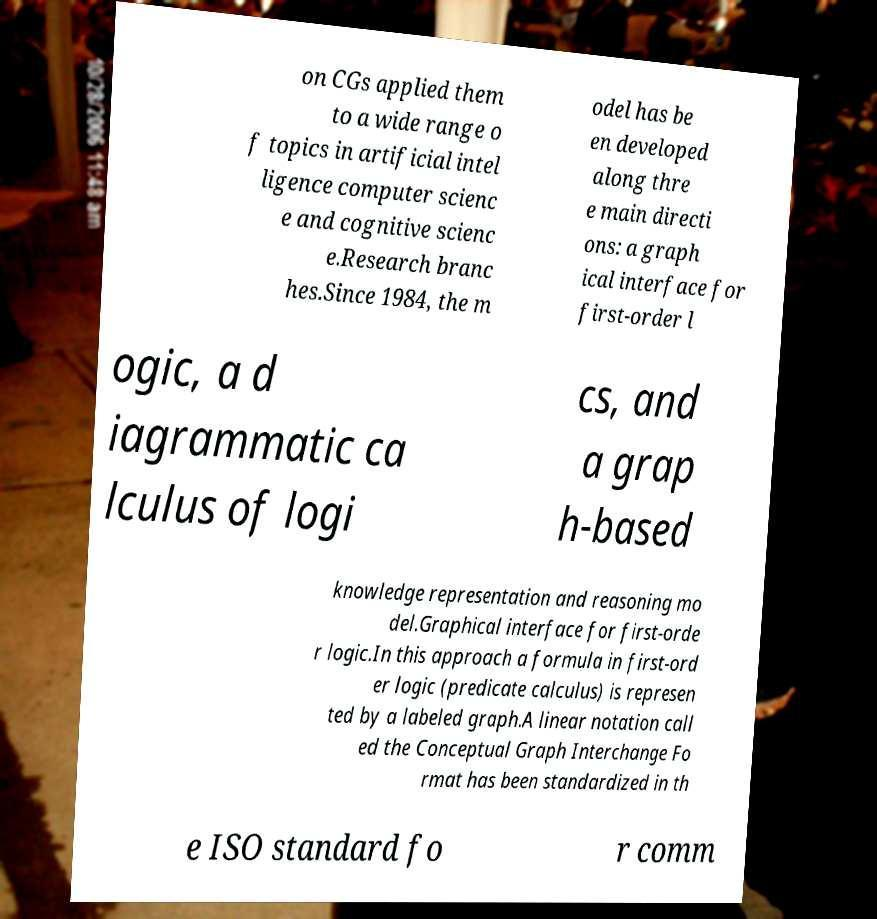I need the written content from this picture converted into text. Can you do that? on CGs applied them to a wide range o f topics in artificial intel ligence computer scienc e and cognitive scienc e.Research branc hes.Since 1984, the m odel has be en developed along thre e main directi ons: a graph ical interface for first-order l ogic, a d iagrammatic ca lculus of logi cs, and a grap h-based knowledge representation and reasoning mo del.Graphical interface for first-orde r logic.In this approach a formula in first-ord er logic (predicate calculus) is represen ted by a labeled graph.A linear notation call ed the Conceptual Graph Interchange Fo rmat has been standardized in th e ISO standard fo r comm 